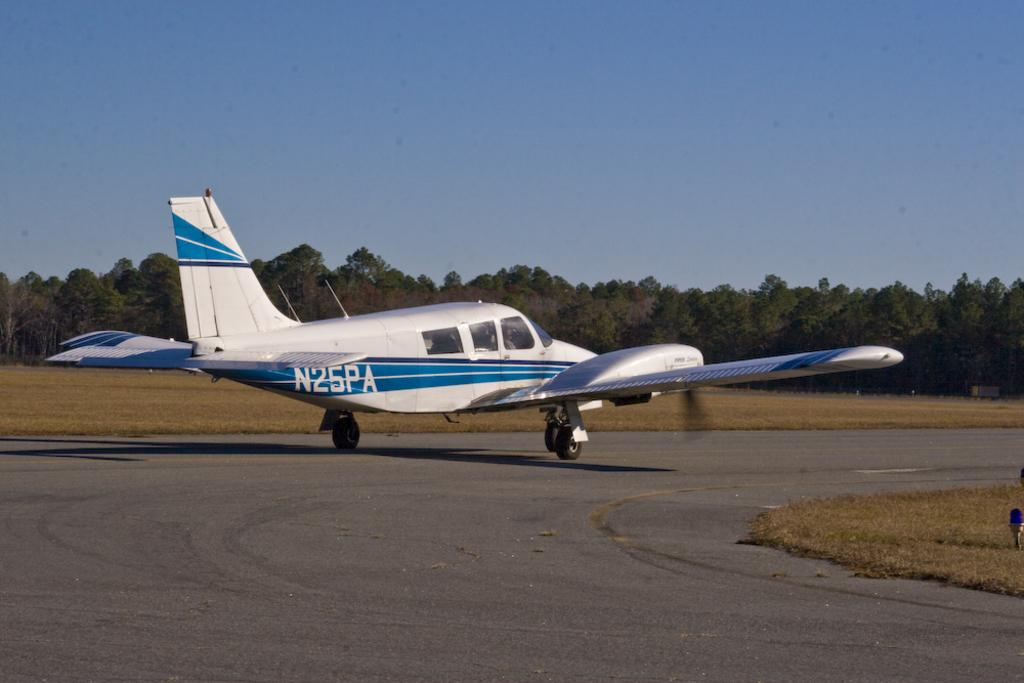Provide a one-sentence caption for the provided image. the label N25PA is on the back of a plane. 